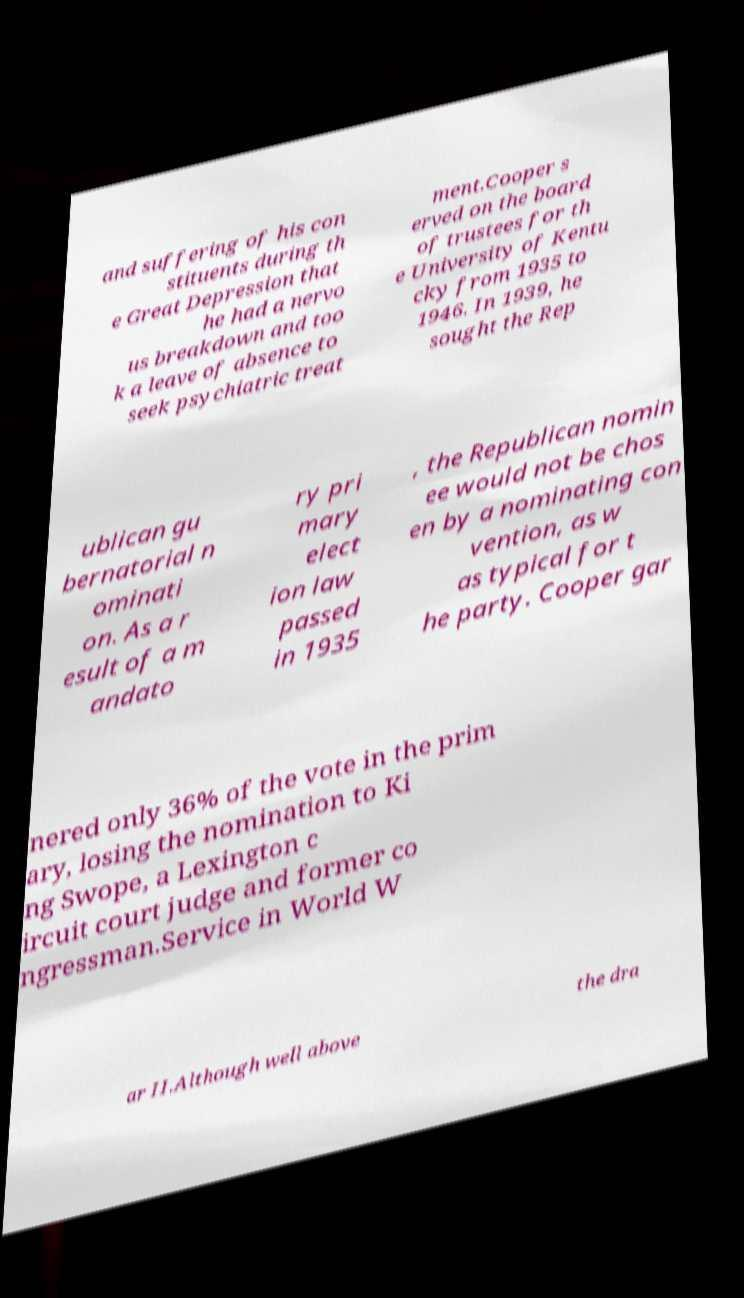Can you accurately transcribe the text from the provided image for me? and suffering of his con stituents during th e Great Depression that he had a nervo us breakdown and too k a leave of absence to seek psychiatric treat ment.Cooper s erved on the board of trustees for th e University of Kentu cky from 1935 to 1946. In 1939, he sought the Rep ublican gu bernatorial n ominati on. As a r esult of a m andato ry pri mary elect ion law passed in 1935 , the Republican nomin ee would not be chos en by a nominating con vention, as w as typical for t he party. Cooper gar nered only 36% of the vote in the prim ary, losing the nomination to Ki ng Swope, a Lexington c ircuit court judge and former co ngressman.Service in World W ar II.Although well above the dra 